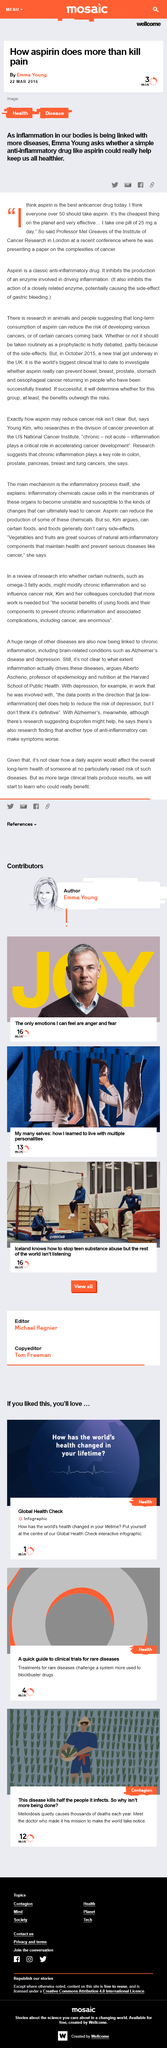Give some essential details in this illustration. This article is tagged as covering the topics of health and disease. Professor Mel Greaves takes approximately 25 milligrams of aspirin per day. According to Professor Mel Greaves, the most effective anticancer drug currently available is aspirin. 